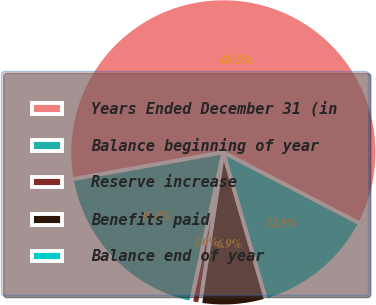Convert chart to OTSL. <chart><loc_0><loc_0><loc_500><loc_500><pie_chart><fcel>Years Ended December 31 (in<fcel>Balance beginning of year<fcel>Reserve increase<fcel>Benefits paid<fcel>Balance end of year<nl><fcel>60.46%<fcel>18.81%<fcel>0.96%<fcel>6.91%<fcel>12.86%<nl></chart> 